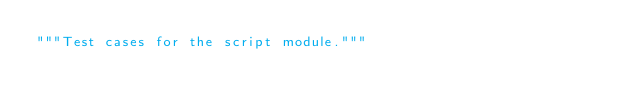<code> <loc_0><loc_0><loc_500><loc_500><_Python_>"""Test cases for the script module."""
</code> 